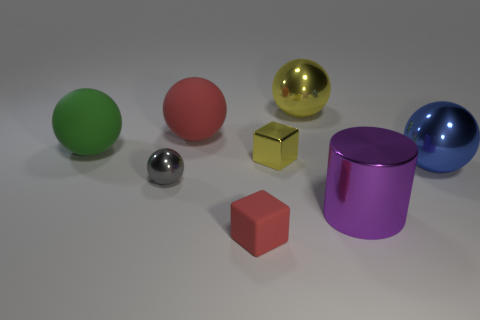Subtract all yellow metallic spheres. How many spheres are left? 4 Subtract 3 balls. How many balls are left? 2 Add 1 small yellow objects. How many objects exist? 9 Subtract all yellow spheres. How many spheres are left? 4 Subtract all cyan balls. Subtract all brown blocks. How many balls are left? 5 Subtract all purple cylinders. Subtract all large yellow metallic things. How many objects are left? 6 Add 5 large shiny objects. How many large shiny objects are left? 8 Add 4 tiny blue metal cylinders. How many tiny blue metal cylinders exist? 4 Subtract 0 purple balls. How many objects are left? 8 Subtract all balls. How many objects are left? 3 